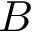<formula> <loc_0><loc_0><loc_500><loc_500>B</formula> 